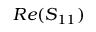Convert formula to latex. <formula><loc_0><loc_0><loc_500><loc_500>R e ( S _ { 1 1 } )</formula> 